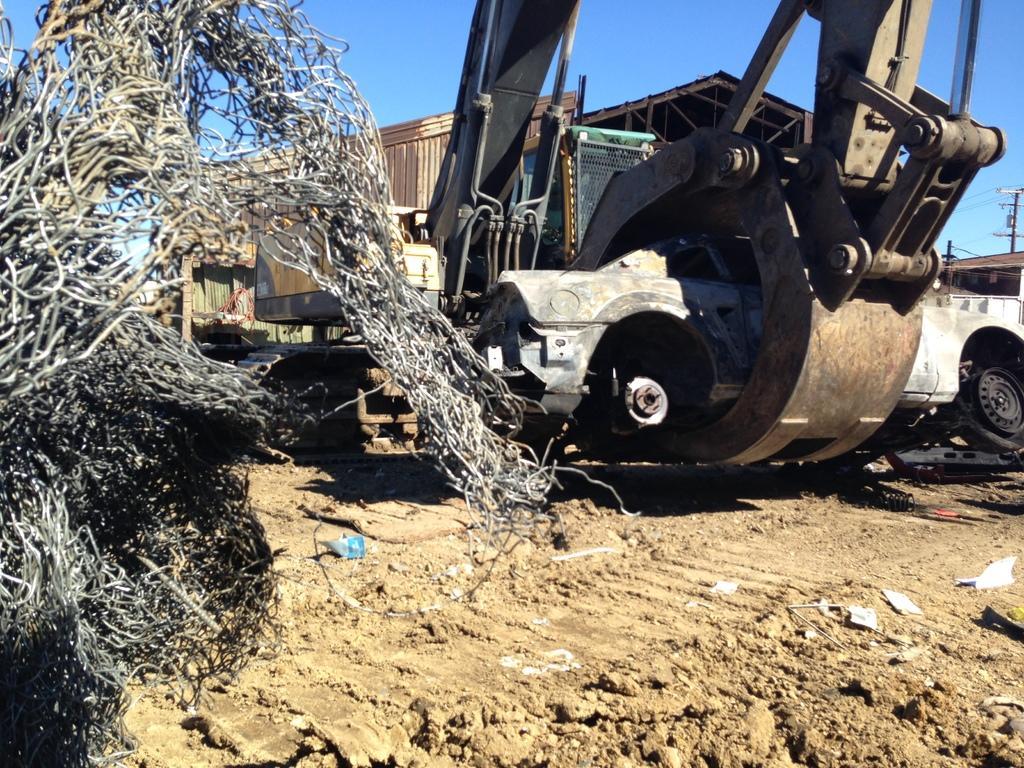How would you summarize this image in a sentence or two? In this image there is the sky truncated towards the top of the image, there is a pole truncated towards the right of the image, there are wires, there is a vigil truncated towards the right of the image, there is soil truncated towards the bottom of the image, there are objects on the soil, there is an object truncated towards the left of the image. 